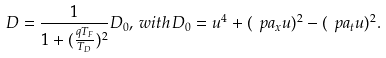Convert formula to latex. <formula><loc_0><loc_0><loc_500><loc_500>D = \frac { 1 } { 1 + ( \frac { q T _ { F } } { T _ { D } } ) ^ { 2 } } D _ { 0 } , \, w i t h \, D _ { 0 } = u ^ { 4 } + ( \ p a _ { x } u ) ^ { 2 } - ( \ p a _ { t } u ) ^ { 2 } .</formula> 